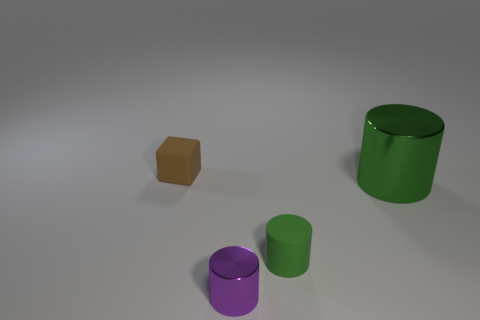Add 2 large cyan matte cylinders. How many objects exist? 6 Subtract all cylinders. How many objects are left? 1 Add 2 small green matte things. How many small green matte things are left? 3 Add 1 gray metallic cubes. How many gray metallic cubes exist? 1 Subtract 0 green blocks. How many objects are left? 4 Subtract all big red rubber objects. Subtract all green metallic things. How many objects are left? 3 